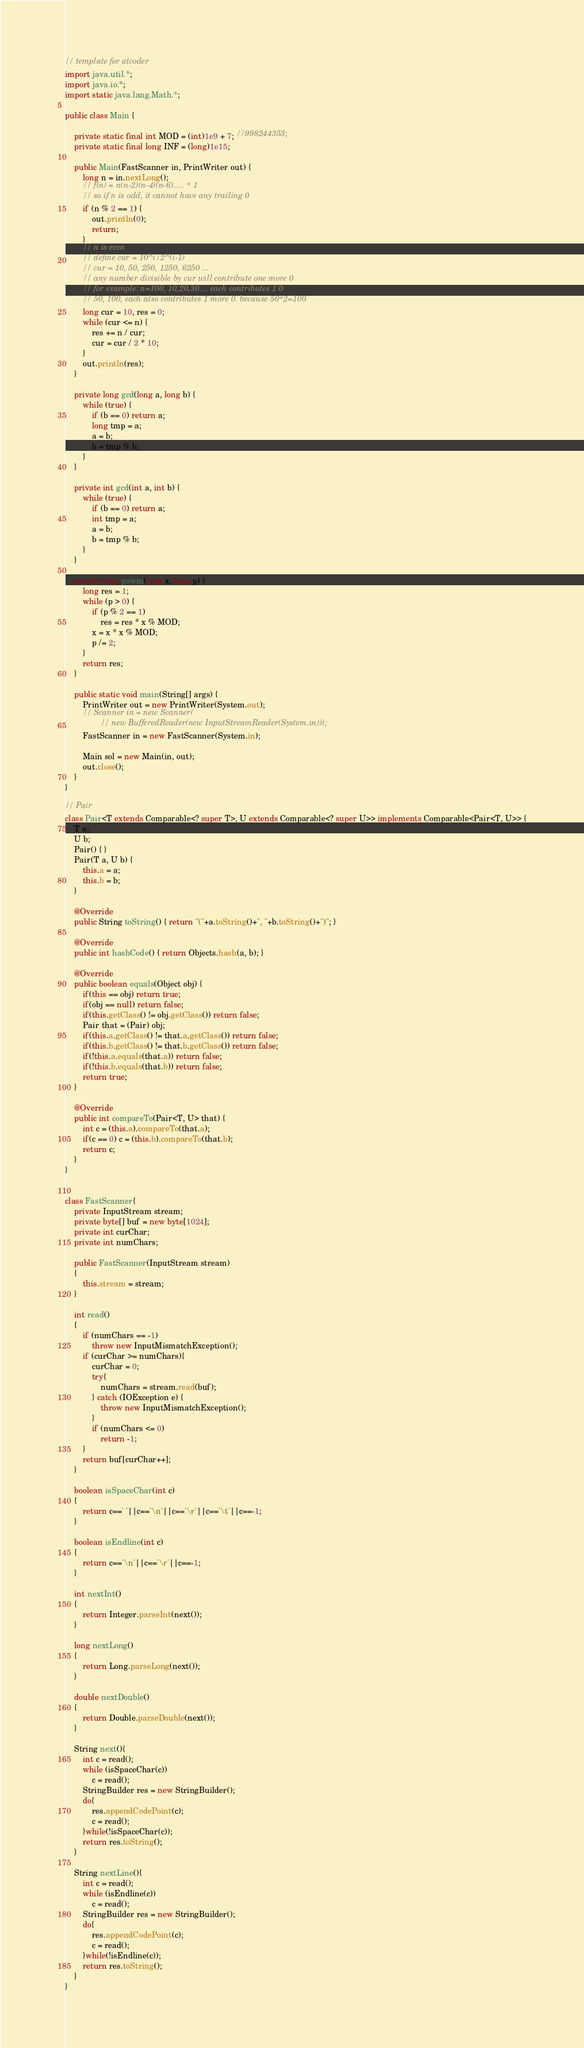Convert code to text. <code><loc_0><loc_0><loc_500><loc_500><_Java_>// template for atcoder
import java.util.*;
import java.io.*;
import static java.lang.Math.*;

public class Main {

    private static final int MOD = (int)1e9 + 7; //998244353;
    private static final long INF = (long)1e15;

    public Main(FastScanner in, PrintWriter out) {
        long n = in.nextLong();
        // f(n) = n(n-2)(n-4)(n-6)..... * 1
        // so if n is odd, it cannot have any trailing 0
        if (n % 2 == 1) {
            out.println(0);
            return;
        }
        // n is even
        // define cur = 10^i/2^(i-1)
        // cur = 10, 50, 250, 1250, 6250 ... 
        // any number divisible by cur will contribute one more 0
        // for example: n=100, 10,20,30 ... each contributes 1 0
        // 50, 100, each also contributes 1 more 0. because 50*2=100
        long cur = 10, res = 0;
        while (cur <= n) {
            res += n / cur;
            cur = cur / 2 * 10;
        }
        out.println(res);
    }

    private long gcd(long a, long b) {
        while (true) {
            if (b == 0) return a;
            long tmp = a;
            a = b;
            b = tmp % b;
        }
    }

    private int gcd(int a, int b) {
        while (true) {
            if (b == 0) return a;
            int tmp = a;
            a = b;
            b = tmp % b;
        }
    }

    private long powm(long x, long p) {
        long res = 1;
        while (p > 0) {
            if (p % 2 == 1)
                res = res * x % MOD;
            x = x * x % MOD;
            p /= 2;
        }
        return res;
    }

    public static void main(String[] args) {
        PrintWriter out = new PrintWriter(System.out);
        // Scanner in = new Scanner(
                // new BufferedReader(new InputStreamReader(System.in)));
        FastScanner in = new FastScanner(System.in);

        Main sol = new Main(in, out);
        out.close();
    }
}

// Pair
class Pair<T extends Comparable<? super T>, U extends Comparable<? super U>> implements Comparable<Pair<T, U>> {
    T a;
    U b;
    Pair() { }
    Pair(T a, U b) {
        this.a = a;
        this.b = b;
    }

    @Override
    public String toString() { return "("+a.toString()+", "+b.toString()+")"; }

    @Override
    public int hashCode() { return Objects.hash(a, b); }

    @Override
    public boolean equals(Object obj) {
        if(this == obj) return true;
        if(obj == null) return false;
        if(this.getClass() != obj.getClass()) return false;
        Pair that = (Pair) obj;
        if(this.a.getClass() != that.a.getClass()) return false;
        if(this.b.getClass() != that.b.getClass()) return false;
        if(!this.a.equals(that.a)) return false;
        if(!this.b.equals(that.b)) return false;
        return true;
    }

    @Override
    public int compareTo(Pair<T, U> that) {
        int c = (this.a).compareTo(that.a);
        if(c == 0) c = (this.b).compareTo(that.b);
        return c;
    }
}


class FastScanner{
    private InputStream stream;
    private byte[] buf = new byte[1024];
    private int curChar;
    private int numChars;

    public FastScanner(InputStream stream)
    {
        this.stream = stream;
    }

    int read()
    {
        if (numChars == -1)
            throw new InputMismatchException();
        if (curChar >= numChars){
            curChar = 0;
            try{
                numChars = stream.read(buf);
            } catch (IOException e) {
                throw new InputMismatchException();
            }
            if (numChars <= 0)
                return -1;
        }
        return buf[curChar++];
    }

    boolean isSpaceChar(int c)
    {
        return c==' '||c=='\n'||c=='\r'||c=='\t'||c==-1;
    }

    boolean isEndline(int c)
    {
        return c=='\n'||c=='\r'||c==-1;
    }

    int nextInt()
    {
        return Integer.parseInt(next());
    }

    long nextLong()
    {
        return Long.parseLong(next());
    }

    double nextDouble()
    {
        return Double.parseDouble(next());
    }

    String next(){
        int c = read();
        while (isSpaceChar(c))
            c = read();
        StringBuilder res = new StringBuilder();
        do{
            res.appendCodePoint(c);
            c = read();
        }while(!isSpaceChar(c));
        return res.toString();
    }

    String nextLine(){
        int c = read();
        while (isEndline(c))
            c = read();
        StringBuilder res = new StringBuilder();
        do{
            res.appendCodePoint(c);
            c = read();
        }while(!isEndline(c));
        return res.toString();
    }
}
</code> 